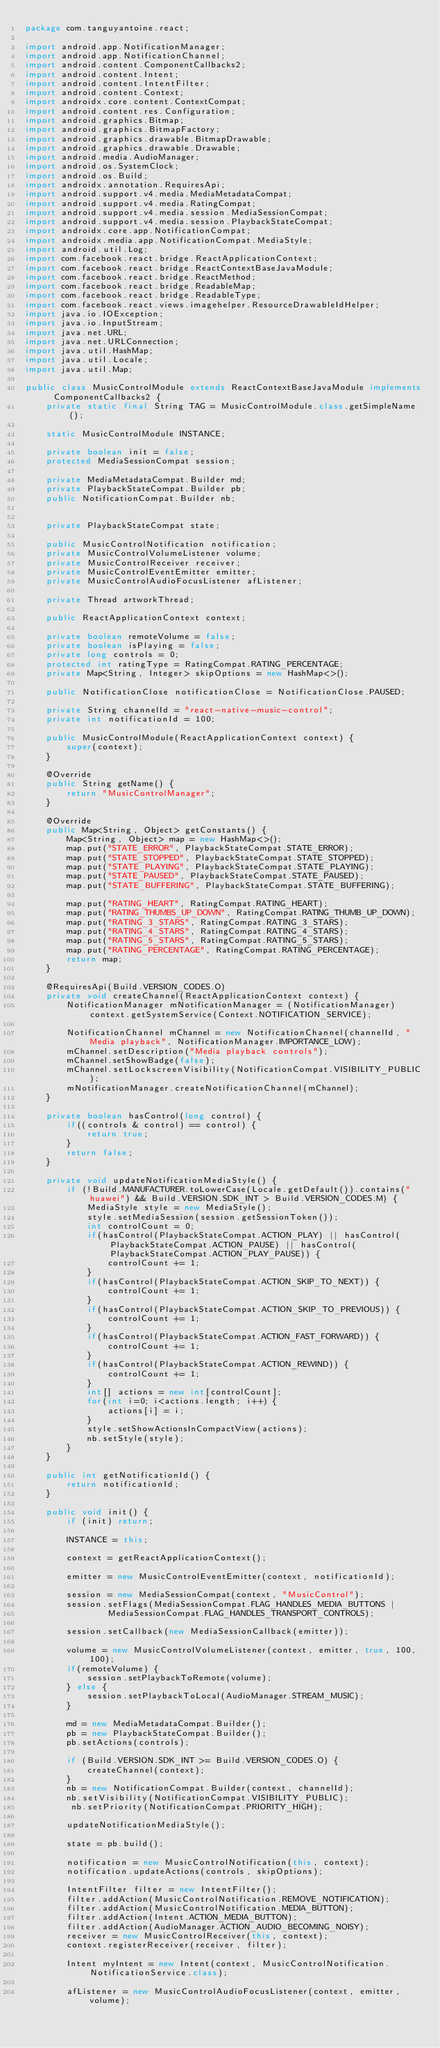Convert code to text. <code><loc_0><loc_0><loc_500><loc_500><_Java_>package com.tanguyantoine.react;

import android.app.NotificationManager;
import android.app.NotificationChannel;
import android.content.ComponentCallbacks2;
import android.content.Intent;
import android.content.IntentFilter;
import android.content.Context;
import androidx.core.content.ContextCompat;
import android.content.res.Configuration;
import android.graphics.Bitmap;
import android.graphics.BitmapFactory;
import android.graphics.drawable.BitmapDrawable;
import android.graphics.drawable.Drawable;
import android.media.AudioManager;
import android.os.SystemClock;
import android.os.Build;
import androidx.annotation.RequiresApi;
import android.support.v4.media.MediaMetadataCompat;
import android.support.v4.media.RatingCompat;
import android.support.v4.media.session.MediaSessionCompat;
import android.support.v4.media.session.PlaybackStateCompat;
import androidx.core.app.NotificationCompat;
import androidx.media.app.NotificationCompat.MediaStyle;
import android.util.Log;
import com.facebook.react.bridge.ReactApplicationContext;
import com.facebook.react.bridge.ReactContextBaseJavaModule;
import com.facebook.react.bridge.ReactMethod;
import com.facebook.react.bridge.ReadableMap;
import com.facebook.react.bridge.ReadableType;
import com.facebook.react.views.imagehelper.ResourceDrawableIdHelper;
import java.io.IOException;
import java.io.InputStream;
import java.net.URL;
import java.net.URLConnection;
import java.util.HashMap;
import java.util.Locale;
import java.util.Map;

public class MusicControlModule extends ReactContextBaseJavaModule implements ComponentCallbacks2 {
    private static final String TAG = MusicControlModule.class.getSimpleName();

    static MusicControlModule INSTANCE;

    private boolean init = false;
    protected MediaSessionCompat session;

    private MediaMetadataCompat.Builder md;
    private PlaybackStateCompat.Builder pb;
    public NotificationCompat.Builder nb;


    private PlaybackStateCompat state;

    public MusicControlNotification notification;
    private MusicControlVolumeListener volume;
    private MusicControlReceiver receiver;
    private MusicControlEventEmitter emitter;
    private MusicControlAudioFocusListener afListener;

    private Thread artworkThread;

    public ReactApplicationContext context;

    private boolean remoteVolume = false;
    private boolean isPlaying = false;
    private long controls = 0;
    protected int ratingType = RatingCompat.RATING_PERCENTAGE;
    private Map<String, Integer> skipOptions = new HashMap<>();

    public NotificationClose notificationClose = NotificationClose.PAUSED;

    private String channelId = "react-native-music-control";
    private int notificationId = 100;

    public MusicControlModule(ReactApplicationContext context) {
        super(context);
    }

    @Override
    public String getName() {
        return "MusicControlManager";
    }

    @Override
    public Map<String, Object> getConstants() {
        Map<String, Object> map = new HashMap<>();
        map.put("STATE_ERROR", PlaybackStateCompat.STATE_ERROR);
        map.put("STATE_STOPPED", PlaybackStateCompat.STATE_STOPPED);
        map.put("STATE_PLAYING", PlaybackStateCompat.STATE_PLAYING);
        map.put("STATE_PAUSED", PlaybackStateCompat.STATE_PAUSED);
        map.put("STATE_BUFFERING", PlaybackStateCompat.STATE_BUFFERING);

        map.put("RATING_HEART", RatingCompat.RATING_HEART);
        map.put("RATING_THUMBS_UP_DOWN", RatingCompat.RATING_THUMB_UP_DOWN);
        map.put("RATING_3_STARS", RatingCompat.RATING_3_STARS);
        map.put("RATING_4_STARS", RatingCompat.RATING_4_STARS);
        map.put("RATING_5_STARS", RatingCompat.RATING_5_STARS);
        map.put("RATING_PERCENTAGE", RatingCompat.RATING_PERCENTAGE);
        return map;
    }

    @RequiresApi(Build.VERSION_CODES.O)
    private void createChannel(ReactApplicationContext context) {
        NotificationManager mNotificationManager = (NotificationManager) context.getSystemService(Context.NOTIFICATION_SERVICE);

        NotificationChannel mChannel = new NotificationChannel(channelId, "Media playback", NotificationManager.IMPORTANCE_LOW);
        mChannel.setDescription("Media playback controls");
        mChannel.setShowBadge(false);
        mChannel.setLockscreenVisibility(NotificationCompat.VISIBILITY_PUBLIC);
        mNotificationManager.createNotificationChannel(mChannel);
    }

    private boolean hasControl(long control) {
        if((controls & control) == control) {
            return true;
        }
        return false;
    }

    private void updateNotificationMediaStyle() {
        if (!Build.MANUFACTURER.toLowerCase(Locale.getDefault()).contains("huawei") && Build.VERSION.SDK_INT > Build.VERSION_CODES.M) {
            MediaStyle style = new MediaStyle();
            style.setMediaSession(session.getSessionToken());
            int controlCount = 0;
            if(hasControl(PlaybackStateCompat.ACTION_PLAY) || hasControl(PlaybackStateCompat.ACTION_PAUSE) || hasControl(PlaybackStateCompat.ACTION_PLAY_PAUSE)) {
                controlCount += 1;
            }
            if(hasControl(PlaybackStateCompat.ACTION_SKIP_TO_NEXT)) {
                controlCount += 1;
            }
            if(hasControl(PlaybackStateCompat.ACTION_SKIP_TO_PREVIOUS)) {
                controlCount += 1;
            }
            if(hasControl(PlaybackStateCompat.ACTION_FAST_FORWARD)) {
                controlCount += 1;
            }
            if(hasControl(PlaybackStateCompat.ACTION_REWIND)) {
                controlCount += 1;
            }
            int[] actions = new int[controlCount];
            for(int i=0; i<actions.length; i++) {
                actions[i] = i;
            }
            style.setShowActionsInCompactView(actions);
            nb.setStyle(style);
        }
    }

    public int getNotificationId() {
        return notificationId;
    }

    public void init() {
        if (init) return;

        INSTANCE = this;

        context = getReactApplicationContext();

        emitter = new MusicControlEventEmitter(context, notificationId);

        session = new MediaSessionCompat(context, "MusicControl");
        session.setFlags(MediaSessionCompat.FLAG_HANDLES_MEDIA_BUTTONS |
                MediaSessionCompat.FLAG_HANDLES_TRANSPORT_CONTROLS);

        session.setCallback(new MediaSessionCallback(emitter));

        volume = new MusicControlVolumeListener(context, emitter, true, 100, 100);
        if(remoteVolume) {
            session.setPlaybackToRemote(volume);
        } else {
            session.setPlaybackToLocal(AudioManager.STREAM_MUSIC);
        }

        md = new MediaMetadataCompat.Builder();
        pb = new PlaybackStateCompat.Builder();
        pb.setActions(controls);

        if (Build.VERSION.SDK_INT >= Build.VERSION_CODES.O) {
            createChannel(context);
        }
        nb = new NotificationCompat.Builder(context, channelId);
        nb.setVisibility(NotificationCompat.VISIBILITY_PUBLIC);
         nb.setPriority(NotificationCompat.PRIORITY_HIGH);

        updateNotificationMediaStyle();

        state = pb.build();

        notification = new MusicControlNotification(this, context);
        notification.updateActions(controls, skipOptions);

        IntentFilter filter = new IntentFilter();
        filter.addAction(MusicControlNotification.REMOVE_NOTIFICATION);
        filter.addAction(MusicControlNotification.MEDIA_BUTTON);
        filter.addAction(Intent.ACTION_MEDIA_BUTTON);
        filter.addAction(AudioManager.ACTION_AUDIO_BECOMING_NOISY);
        receiver = new MusicControlReceiver(this, context);
        context.registerReceiver(receiver, filter);

        Intent myIntent = new Intent(context, MusicControlNotification.NotificationService.class);

        afListener = new MusicControlAudioFocusListener(context, emitter, volume);
</code> 